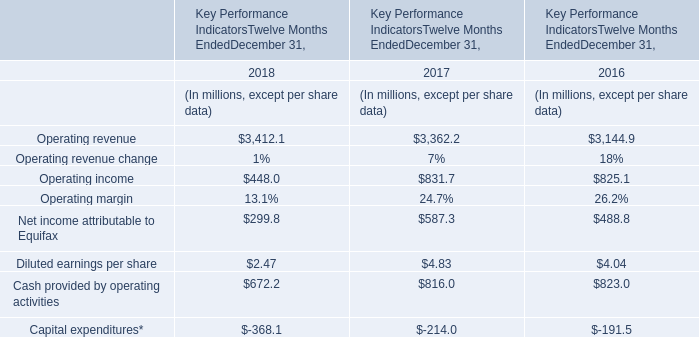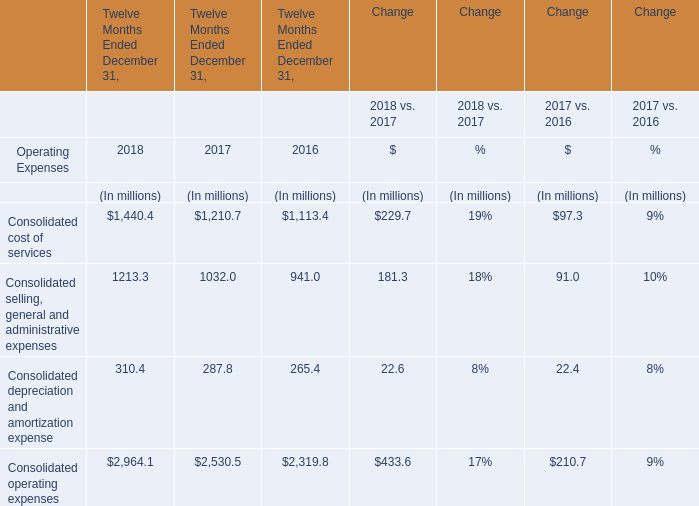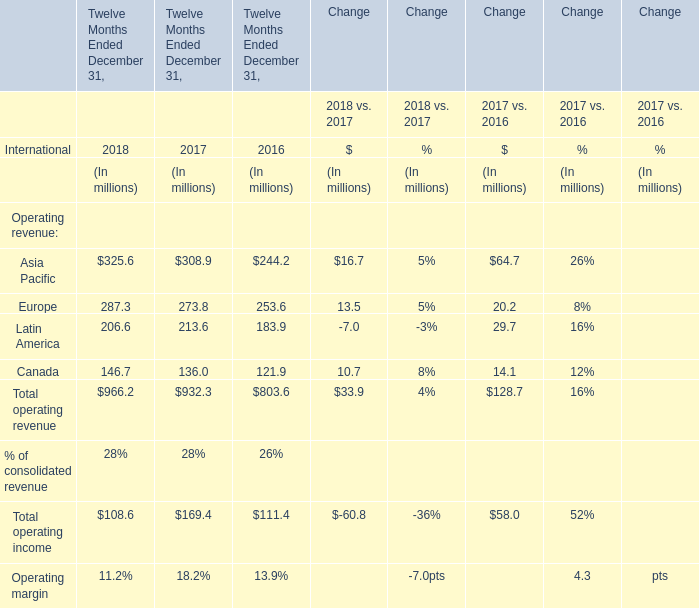In which section the sum of operating revenue has the highest value in that year? 
Answer: Asia Pacific. 